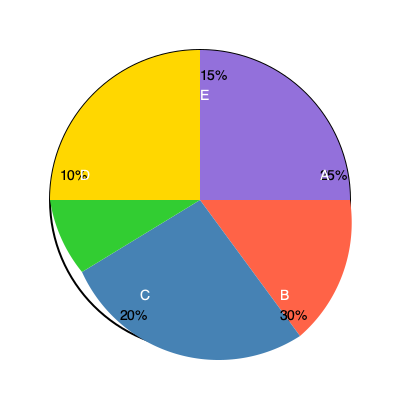Based on the market segmentation pie chart for your invention, which two customer segments should you prioritize when seeking a business partner, and what percentage of the total market do they represent combined? To answer this question, we need to analyze the market segmentation pie chart and identify the two largest segments. Here's the step-by-step process:

1. Examine all segments in the pie chart:
   Segment A: 25%
   Segment B: 30%
   Segment C: 20%
   Segment D: 10%
   Segment E: 15%

2. Identify the two largest segments:
   The largest segment is B with 30%
   The second-largest segment is A with 25%

3. Calculate the combined percentage of these two segments:
   $30\% + 25\% = 55\%$

4. Interpret the result:
   Segments B and A represent the largest potential customer bases for your invention. Prioritizing these segments when seeking a business partner would target the majority of your potential market.

5. Formulate the answer:
   The two segments to prioritize are B and A, which together represent 55% of the total market.
Answer: Segments B and A, 55% 